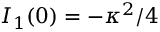<formula> <loc_0><loc_0><loc_500><loc_500>I _ { 1 } ( 0 ) = - \kappa ^ { 2 } / 4</formula> 